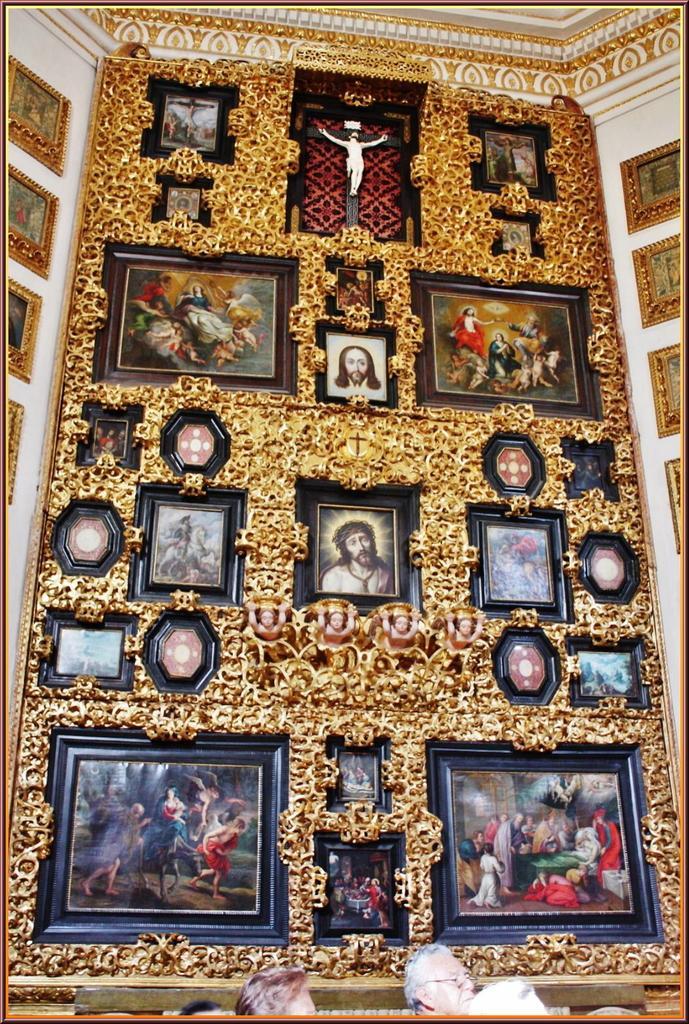Could you give a brief overview of what you see in this image? In this image I can see a big frame on which there are many photographs. On the right and left side of the image there are few frames attached to the wall. 